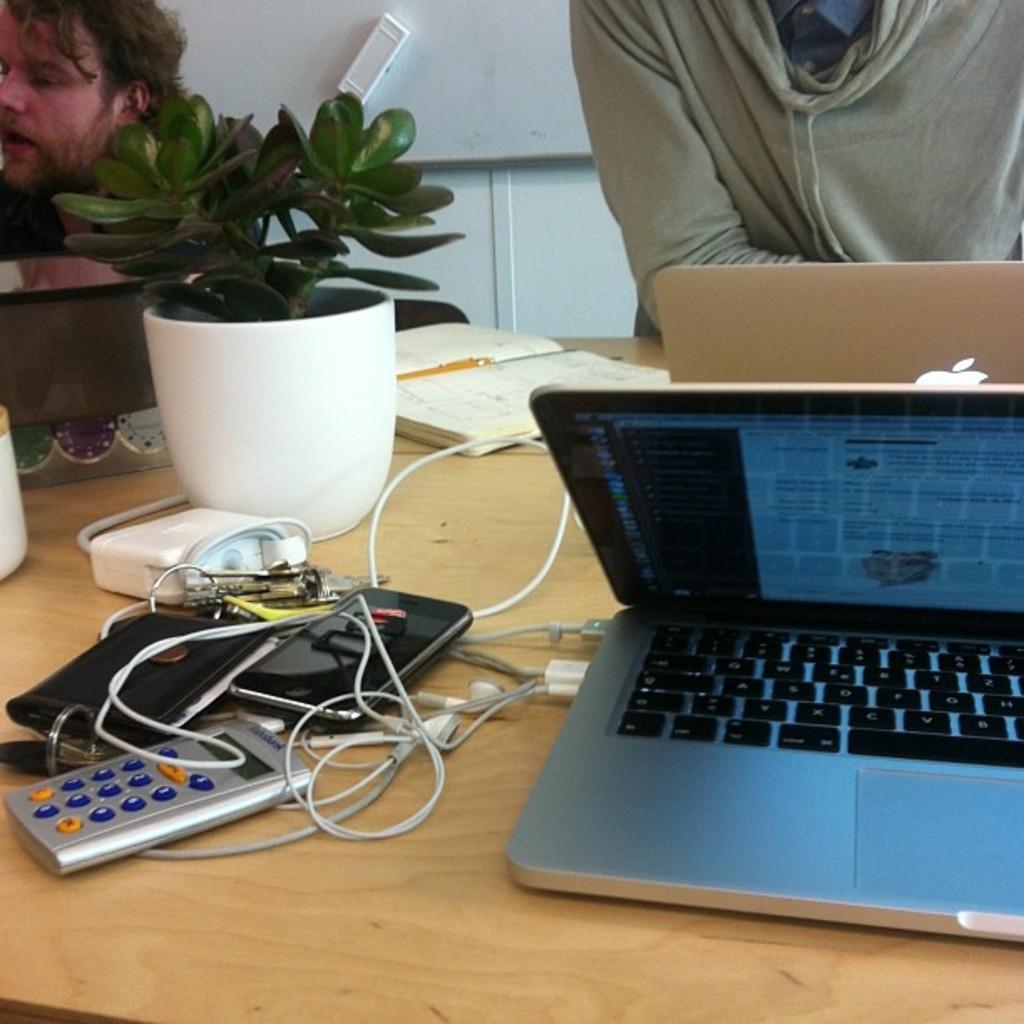How would you summarize this image in a sentence or two? In this picture we can see two persons near to the table and on the table we can see houseplant, gadgets, laptop, headsets, pen and a book. 